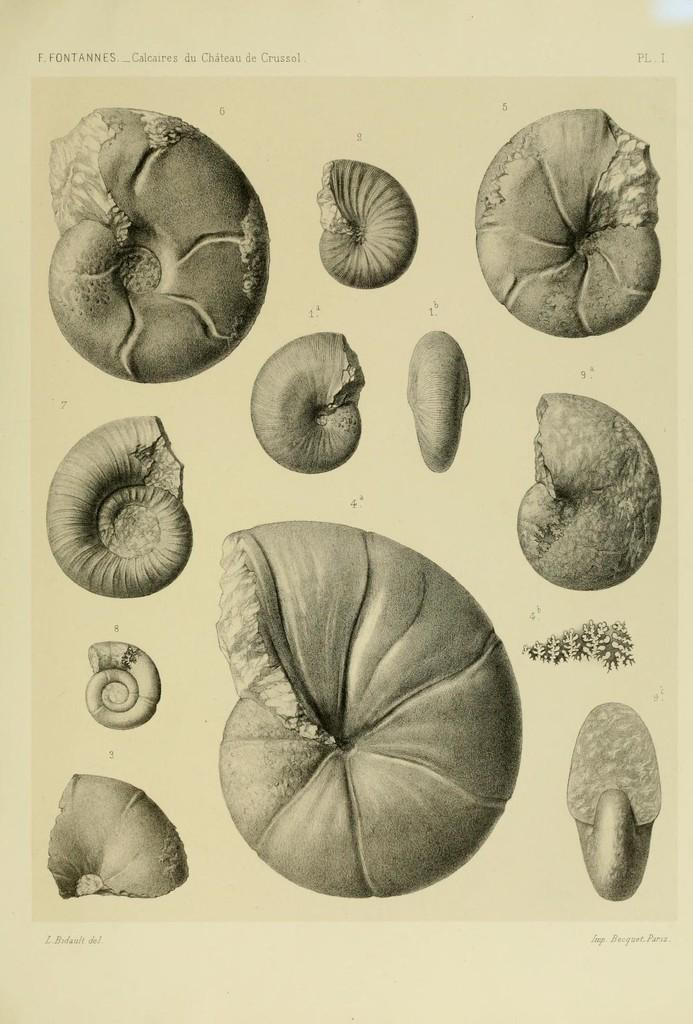What is the main subject of the image? There is an art piece in the image. What is depicted in the art piece? The art piece features snail shells. How are the snail shells represented in the art piece? The snail shells are depicted on paper. What is the temperature of the screw in the image? There is no screw present in the image, so it is not possible to determine its temperature. 